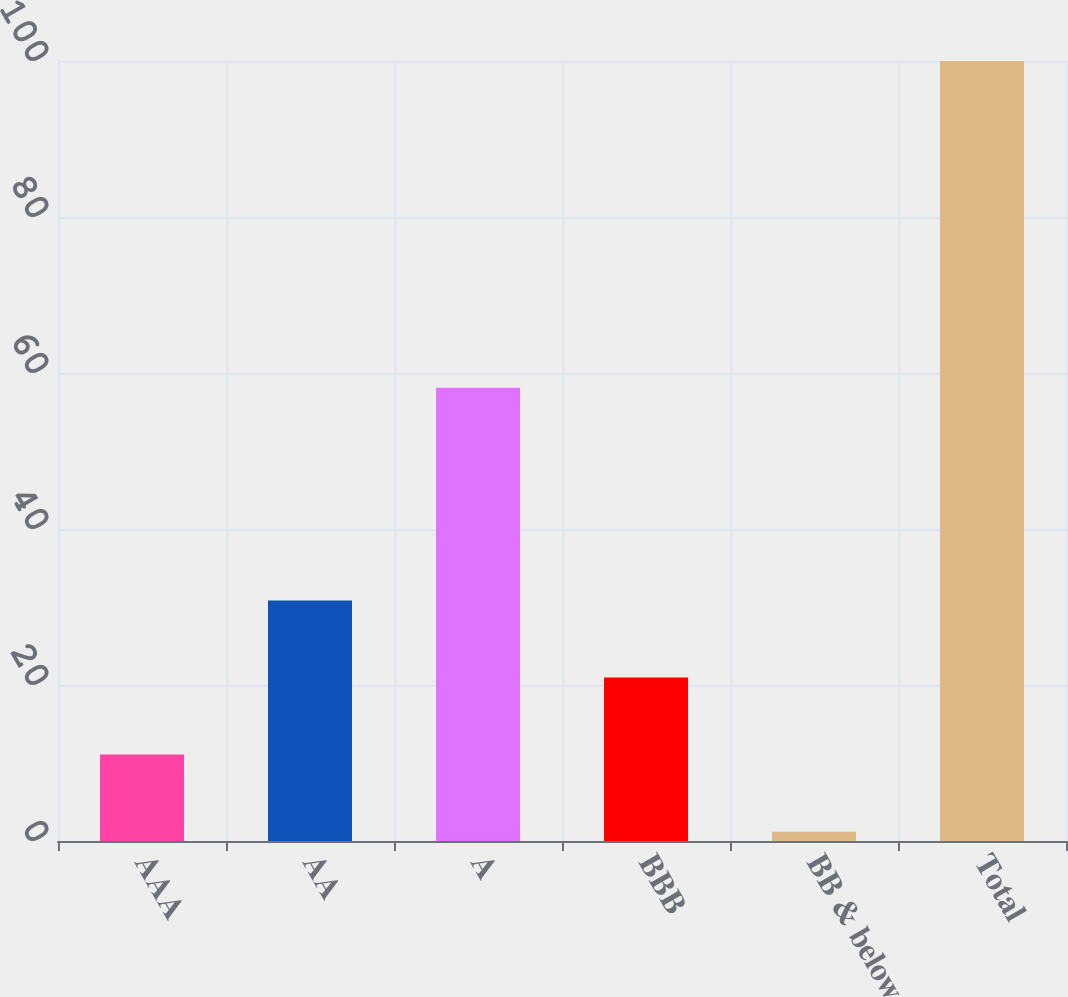Convert chart. <chart><loc_0><loc_0><loc_500><loc_500><bar_chart><fcel>AAA<fcel>AA<fcel>A<fcel>BBB<fcel>BB & below<fcel>Total<nl><fcel>11.08<fcel>30.84<fcel>58.1<fcel>20.96<fcel>1.2<fcel>100<nl></chart> 